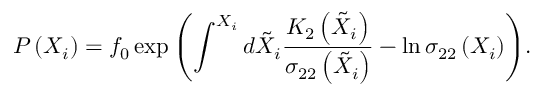<formula> <loc_0><loc_0><loc_500><loc_500>P \left ( X _ { i } \right ) = f _ { 0 } \exp { \left ( \int ^ { X _ { i } } d \tilde { X } _ { i } \frac { K _ { 2 } \left ( \tilde { X } _ { i } \right ) } { \sigma _ { 2 2 } \left ( \tilde { X } _ { i } \right ) } - \ln \sigma _ { 2 2 } \left ( X _ { i } \right ) \right ) } .</formula> 